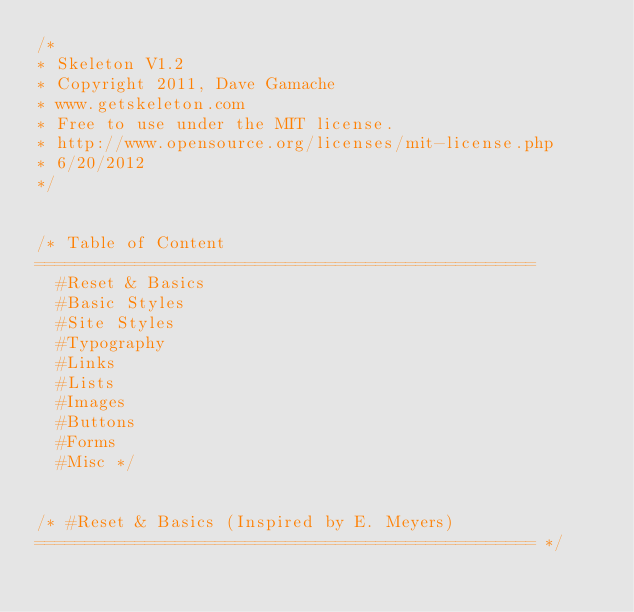Convert code to text. <code><loc_0><loc_0><loc_500><loc_500><_CSS_>/*
* Skeleton V1.2
* Copyright 2011, Dave Gamache
* www.getskeleton.com
* Free to use under the MIT license.
* http://www.opensource.org/licenses/mit-license.php
* 6/20/2012
*/


/* Table of Content
==================================================
	#Reset & Basics
	#Basic Styles
	#Site Styles
	#Typography
	#Links
	#Lists
	#Images
	#Buttons
	#Forms
	#Misc */


/* #Reset & Basics (Inspired by E. Meyers)
================================================== */</code> 